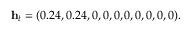Convert formula to latex. <formula><loc_0><loc_0><loc_500><loc_500>h _ { t } = ( 0 . 2 4 , 0 . 2 4 , 0 , 0 , 0 , 0 , 0 , 0 , 0 , 0 ) .</formula> 